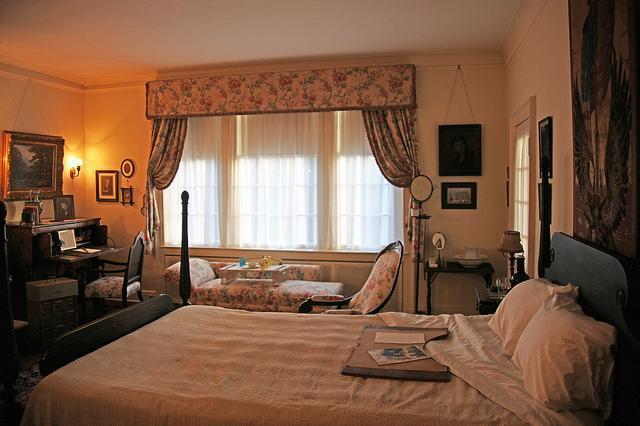How many chairs are in the photo?
Give a very brief answer. 1. 